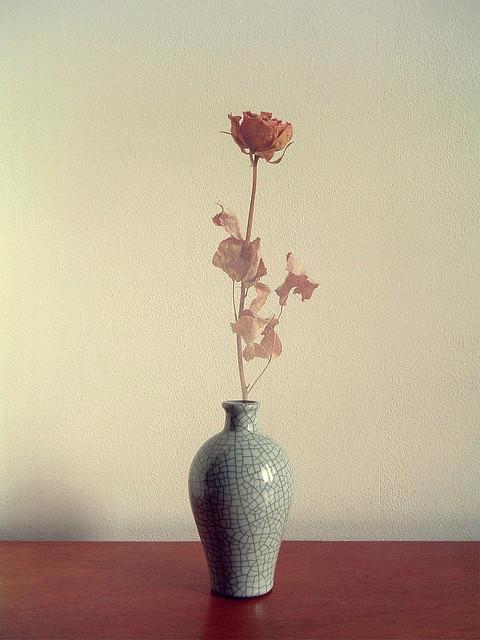Is this vase full of flowers?
Concise answer only. Yes. What pattern is on the vase?
Short answer required. Cracked. What pattern does the vase have?
Write a very short answer. Cracked. Is this pretty?
Write a very short answer. Yes. What type of flower is the tallest?
Quick response, please. Rose. Is this vase in a corner?
Give a very brief answer. No. 